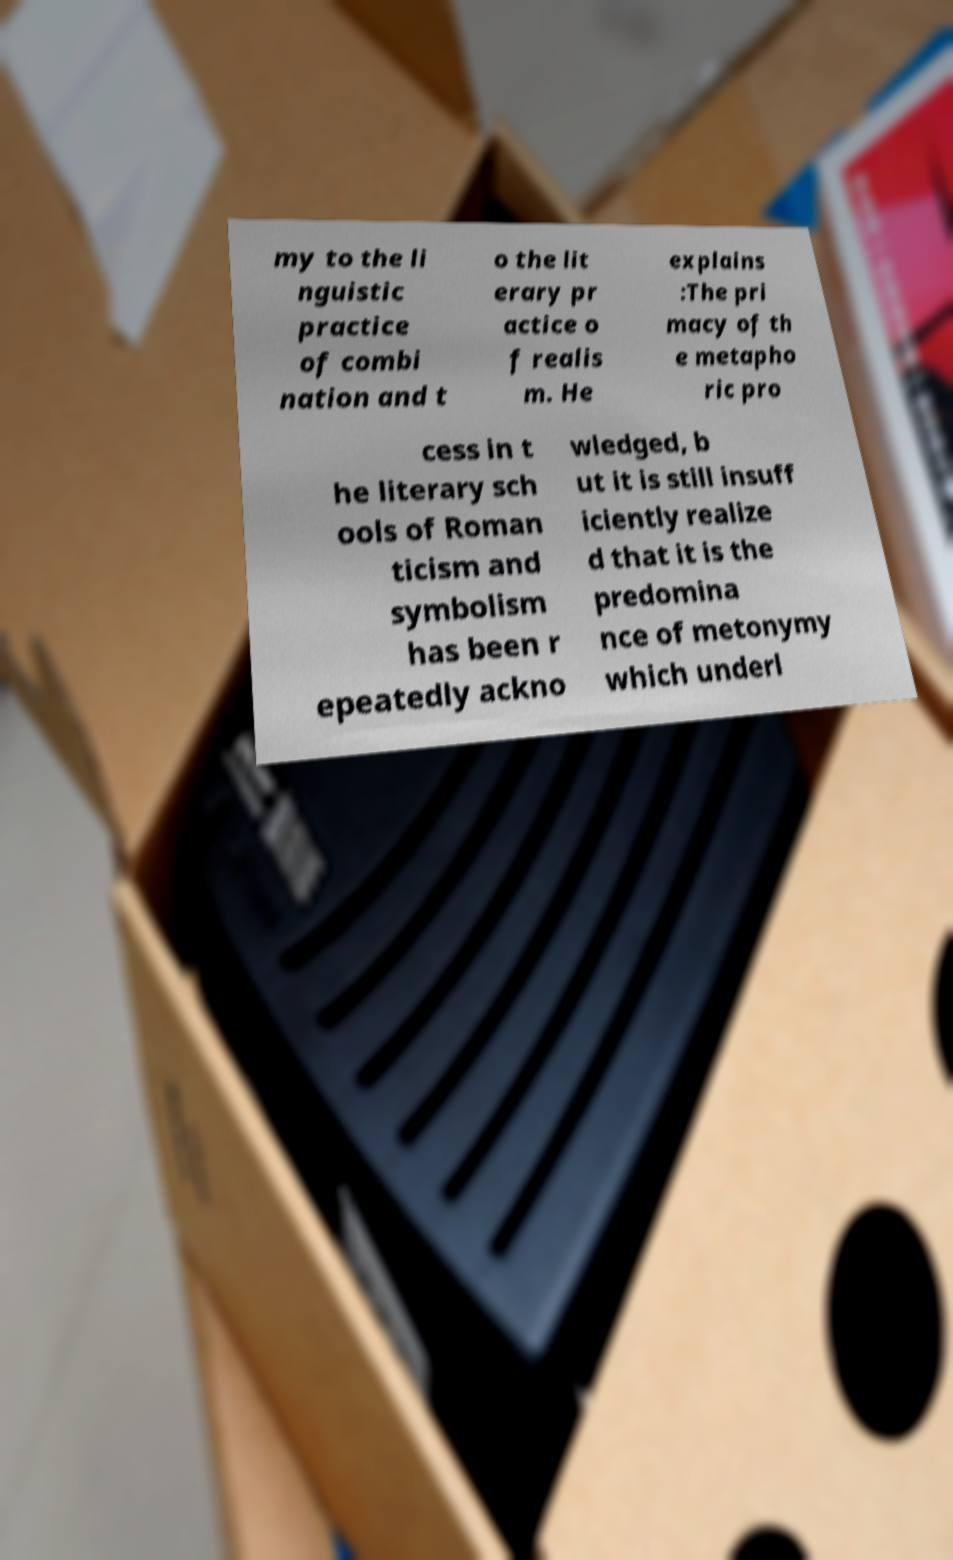I need the written content from this picture converted into text. Can you do that? my to the li nguistic practice of combi nation and t o the lit erary pr actice o f realis m. He explains :The pri macy of th e metapho ric pro cess in t he literary sch ools of Roman ticism and symbolism has been r epeatedly ackno wledged, b ut it is still insuff iciently realize d that it is the predomina nce of metonymy which underl 